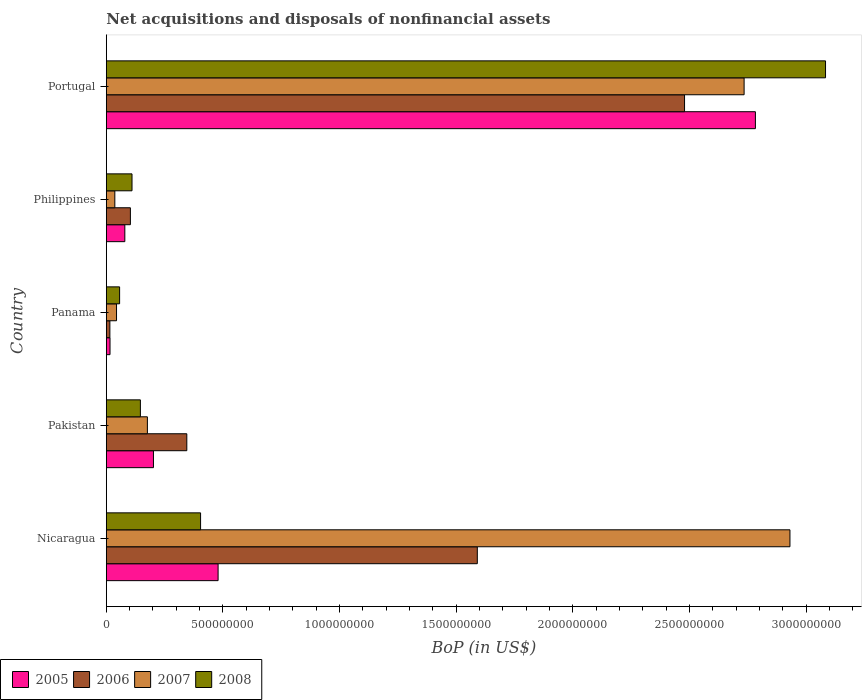How many different coloured bars are there?
Give a very brief answer. 4. Are the number of bars on each tick of the Y-axis equal?
Your answer should be compact. Yes. How many bars are there on the 4th tick from the top?
Give a very brief answer. 4. How many bars are there on the 5th tick from the bottom?
Make the answer very short. 4. In how many cases, is the number of bars for a given country not equal to the number of legend labels?
Your answer should be compact. 0. What is the Balance of Payments in 2006 in Pakistan?
Keep it short and to the point. 3.45e+08. Across all countries, what is the maximum Balance of Payments in 2005?
Ensure brevity in your answer.  2.78e+09. Across all countries, what is the minimum Balance of Payments in 2006?
Offer a very short reply. 1.52e+07. In which country was the Balance of Payments in 2005 maximum?
Give a very brief answer. Portugal. In which country was the Balance of Payments in 2008 minimum?
Make the answer very short. Panama. What is the total Balance of Payments in 2007 in the graph?
Provide a succinct answer. 5.92e+09. What is the difference between the Balance of Payments in 2007 in Panama and that in Portugal?
Ensure brevity in your answer.  -2.69e+09. What is the difference between the Balance of Payments in 2007 in Portugal and the Balance of Payments in 2006 in Pakistan?
Your answer should be compact. 2.39e+09. What is the average Balance of Payments in 2005 per country?
Keep it short and to the point. 7.12e+08. What is the difference between the Balance of Payments in 2007 and Balance of Payments in 2005 in Portugal?
Provide a short and direct response. -4.84e+07. In how many countries, is the Balance of Payments in 2007 greater than 2500000000 US$?
Offer a terse response. 2. What is the ratio of the Balance of Payments in 2006 in Philippines to that in Portugal?
Your answer should be very brief. 0.04. Is the difference between the Balance of Payments in 2007 in Panama and Philippines greater than the difference between the Balance of Payments in 2005 in Panama and Philippines?
Provide a succinct answer. Yes. What is the difference between the highest and the second highest Balance of Payments in 2006?
Offer a very short reply. 8.88e+08. What is the difference between the highest and the lowest Balance of Payments in 2005?
Your response must be concise. 2.77e+09. In how many countries, is the Balance of Payments in 2005 greater than the average Balance of Payments in 2005 taken over all countries?
Give a very brief answer. 1. Is it the case that in every country, the sum of the Balance of Payments in 2008 and Balance of Payments in 2006 is greater than the Balance of Payments in 2007?
Offer a terse response. No. How many countries are there in the graph?
Offer a terse response. 5. Are the values on the major ticks of X-axis written in scientific E-notation?
Your answer should be very brief. No. Does the graph contain any zero values?
Keep it short and to the point. No. Where does the legend appear in the graph?
Offer a very short reply. Bottom left. How are the legend labels stacked?
Your response must be concise. Horizontal. What is the title of the graph?
Provide a succinct answer. Net acquisitions and disposals of nonfinancial assets. Does "2007" appear as one of the legend labels in the graph?
Offer a terse response. Yes. What is the label or title of the X-axis?
Ensure brevity in your answer.  BoP (in US$). What is the BoP (in US$) of 2005 in Nicaragua?
Your answer should be compact. 4.79e+08. What is the BoP (in US$) of 2006 in Nicaragua?
Ensure brevity in your answer.  1.59e+09. What is the BoP (in US$) in 2007 in Nicaragua?
Keep it short and to the point. 2.93e+09. What is the BoP (in US$) of 2008 in Nicaragua?
Offer a terse response. 4.04e+08. What is the BoP (in US$) of 2005 in Pakistan?
Offer a terse response. 2.02e+08. What is the BoP (in US$) in 2006 in Pakistan?
Provide a short and direct response. 3.45e+08. What is the BoP (in US$) in 2007 in Pakistan?
Keep it short and to the point. 1.76e+08. What is the BoP (in US$) in 2008 in Pakistan?
Keep it short and to the point. 1.46e+08. What is the BoP (in US$) in 2005 in Panama?
Offer a very short reply. 1.58e+07. What is the BoP (in US$) in 2006 in Panama?
Keep it short and to the point. 1.52e+07. What is the BoP (in US$) of 2007 in Panama?
Make the answer very short. 4.37e+07. What is the BoP (in US$) in 2008 in Panama?
Ensure brevity in your answer.  5.69e+07. What is the BoP (in US$) in 2005 in Philippines?
Make the answer very short. 7.93e+07. What is the BoP (in US$) of 2006 in Philippines?
Ensure brevity in your answer.  1.03e+08. What is the BoP (in US$) in 2007 in Philippines?
Your answer should be very brief. 3.64e+07. What is the BoP (in US$) of 2008 in Philippines?
Your answer should be compact. 1.10e+08. What is the BoP (in US$) in 2005 in Portugal?
Your response must be concise. 2.78e+09. What is the BoP (in US$) of 2006 in Portugal?
Offer a terse response. 2.48e+09. What is the BoP (in US$) of 2007 in Portugal?
Your response must be concise. 2.73e+09. What is the BoP (in US$) in 2008 in Portugal?
Make the answer very short. 3.08e+09. Across all countries, what is the maximum BoP (in US$) in 2005?
Your response must be concise. 2.78e+09. Across all countries, what is the maximum BoP (in US$) of 2006?
Ensure brevity in your answer.  2.48e+09. Across all countries, what is the maximum BoP (in US$) of 2007?
Keep it short and to the point. 2.93e+09. Across all countries, what is the maximum BoP (in US$) of 2008?
Provide a short and direct response. 3.08e+09. Across all countries, what is the minimum BoP (in US$) of 2005?
Offer a terse response. 1.58e+07. Across all countries, what is the minimum BoP (in US$) of 2006?
Your answer should be compact. 1.52e+07. Across all countries, what is the minimum BoP (in US$) of 2007?
Your answer should be very brief. 3.64e+07. Across all countries, what is the minimum BoP (in US$) of 2008?
Keep it short and to the point. 5.69e+07. What is the total BoP (in US$) of 2005 in the graph?
Provide a short and direct response. 3.56e+09. What is the total BoP (in US$) in 2006 in the graph?
Provide a short and direct response. 4.53e+09. What is the total BoP (in US$) of 2007 in the graph?
Your response must be concise. 5.92e+09. What is the total BoP (in US$) of 2008 in the graph?
Make the answer very short. 3.80e+09. What is the difference between the BoP (in US$) of 2005 in Nicaragua and that in Pakistan?
Offer a terse response. 2.77e+08. What is the difference between the BoP (in US$) of 2006 in Nicaragua and that in Pakistan?
Ensure brevity in your answer.  1.25e+09. What is the difference between the BoP (in US$) in 2007 in Nicaragua and that in Pakistan?
Your response must be concise. 2.75e+09. What is the difference between the BoP (in US$) of 2008 in Nicaragua and that in Pakistan?
Your answer should be very brief. 2.58e+08. What is the difference between the BoP (in US$) in 2005 in Nicaragua and that in Panama?
Keep it short and to the point. 4.63e+08. What is the difference between the BoP (in US$) in 2006 in Nicaragua and that in Panama?
Your answer should be very brief. 1.58e+09. What is the difference between the BoP (in US$) of 2007 in Nicaragua and that in Panama?
Offer a terse response. 2.89e+09. What is the difference between the BoP (in US$) in 2008 in Nicaragua and that in Panama?
Give a very brief answer. 3.47e+08. What is the difference between the BoP (in US$) in 2005 in Nicaragua and that in Philippines?
Your answer should be very brief. 4.00e+08. What is the difference between the BoP (in US$) in 2006 in Nicaragua and that in Philippines?
Provide a succinct answer. 1.49e+09. What is the difference between the BoP (in US$) of 2007 in Nicaragua and that in Philippines?
Ensure brevity in your answer.  2.89e+09. What is the difference between the BoP (in US$) of 2008 in Nicaragua and that in Philippines?
Offer a very short reply. 2.94e+08. What is the difference between the BoP (in US$) of 2005 in Nicaragua and that in Portugal?
Provide a succinct answer. -2.30e+09. What is the difference between the BoP (in US$) in 2006 in Nicaragua and that in Portugal?
Your answer should be compact. -8.88e+08. What is the difference between the BoP (in US$) in 2007 in Nicaragua and that in Portugal?
Offer a terse response. 1.97e+08. What is the difference between the BoP (in US$) of 2008 in Nicaragua and that in Portugal?
Provide a succinct answer. -2.68e+09. What is the difference between the BoP (in US$) in 2005 in Pakistan and that in Panama?
Your answer should be compact. 1.86e+08. What is the difference between the BoP (in US$) of 2006 in Pakistan and that in Panama?
Give a very brief answer. 3.30e+08. What is the difference between the BoP (in US$) of 2007 in Pakistan and that in Panama?
Make the answer very short. 1.32e+08. What is the difference between the BoP (in US$) in 2008 in Pakistan and that in Panama?
Ensure brevity in your answer.  8.91e+07. What is the difference between the BoP (in US$) of 2005 in Pakistan and that in Philippines?
Your response must be concise. 1.23e+08. What is the difference between the BoP (in US$) of 2006 in Pakistan and that in Philippines?
Make the answer very short. 2.42e+08. What is the difference between the BoP (in US$) of 2007 in Pakistan and that in Philippines?
Offer a very short reply. 1.40e+08. What is the difference between the BoP (in US$) of 2008 in Pakistan and that in Philippines?
Your answer should be very brief. 3.59e+07. What is the difference between the BoP (in US$) in 2005 in Pakistan and that in Portugal?
Your answer should be very brief. -2.58e+09. What is the difference between the BoP (in US$) in 2006 in Pakistan and that in Portugal?
Ensure brevity in your answer.  -2.13e+09. What is the difference between the BoP (in US$) in 2007 in Pakistan and that in Portugal?
Your answer should be compact. -2.56e+09. What is the difference between the BoP (in US$) of 2008 in Pakistan and that in Portugal?
Ensure brevity in your answer.  -2.94e+09. What is the difference between the BoP (in US$) of 2005 in Panama and that in Philippines?
Provide a succinct answer. -6.35e+07. What is the difference between the BoP (in US$) of 2006 in Panama and that in Philippines?
Your response must be concise. -8.79e+07. What is the difference between the BoP (in US$) in 2007 in Panama and that in Philippines?
Provide a succinct answer. 7.26e+06. What is the difference between the BoP (in US$) in 2008 in Panama and that in Philippines?
Give a very brief answer. -5.32e+07. What is the difference between the BoP (in US$) in 2005 in Panama and that in Portugal?
Provide a short and direct response. -2.77e+09. What is the difference between the BoP (in US$) of 2006 in Panama and that in Portugal?
Ensure brevity in your answer.  -2.46e+09. What is the difference between the BoP (in US$) of 2007 in Panama and that in Portugal?
Offer a terse response. -2.69e+09. What is the difference between the BoP (in US$) of 2008 in Panama and that in Portugal?
Provide a succinct answer. -3.03e+09. What is the difference between the BoP (in US$) of 2005 in Philippines and that in Portugal?
Your answer should be very brief. -2.70e+09. What is the difference between the BoP (in US$) in 2006 in Philippines and that in Portugal?
Your response must be concise. -2.38e+09. What is the difference between the BoP (in US$) of 2007 in Philippines and that in Portugal?
Offer a terse response. -2.70e+09. What is the difference between the BoP (in US$) of 2008 in Philippines and that in Portugal?
Provide a succinct answer. -2.97e+09. What is the difference between the BoP (in US$) of 2005 in Nicaragua and the BoP (in US$) of 2006 in Pakistan?
Provide a short and direct response. 1.34e+08. What is the difference between the BoP (in US$) in 2005 in Nicaragua and the BoP (in US$) in 2007 in Pakistan?
Keep it short and to the point. 3.03e+08. What is the difference between the BoP (in US$) in 2005 in Nicaragua and the BoP (in US$) in 2008 in Pakistan?
Keep it short and to the point. 3.33e+08. What is the difference between the BoP (in US$) in 2006 in Nicaragua and the BoP (in US$) in 2007 in Pakistan?
Your answer should be very brief. 1.41e+09. What is the difference between the BoP (in US$) of 2006 in Nicaragua and the BoP (in US$) of 2008 in Pakistan?
Your answer should be very brief. 1.44e+09. What is the difference between the BoP (in US$) of 2007 in Nicaragua and the BoP (in US$) of 2008 in Pakistan?
Make the answer very short. 2.78e+09. What is the difference between the BoP (in US$) of 2005 in Nicaragua and the BoP (in US$) of 2006 in Panama?
Your answer should be very brief. 4.64e+08. What is the difference between the BoP (in US$) of 2005 in Nicaragua and the BoP (in US$) of 2007 in Panama?
Your answer should be compact. 4.35e+08. What is the difference between the BoP (in US$) in 2005 in Nicaragua and the BoP (in US$) in 2008 in Panama?
Offer a terse response. 4.22e+08. What is the difference between the BoP (in US$) in 2006 in Nicaragua and the BoP (in US$) in 2007 in Panama?
Ensure brevity in your answer.  1.55e+09. What is the difference between the BoP (in US$) in 2006 in Nicaragua and the BoP (in US$) in 2008 in Panama?
Provide a succinct answer. 1.53e+09. What is the difference between the BoP (in US$) in 2007 in Nicaragua and the BoP (in US$) in 2008 in Panama?
Your response must be concise. 2.87e+09. What is the difference between the BoP (in US$) of 2005 in Nicaragua and the BoP (in US$) of 2006 in Philippines?
Your answer should be compact. 3.76e+08. What is the difference between the BoP (in US$) of 2005 in Nicaragua and the BoP (in US$) of 2007 in Philippines?
Your answer should be compact. 4.43e+08. What is the difference between the BoP (in US$) in 2005 in Nicaragua and the BoP (in US$) in 2008 in Philippines?
Provide a short and direct response. 3.69e+08. What is the difference between the BoP (in US$) in 2006 in Nicaragua and the BoP (in US$) in 2007 in Philippines?
Make the answer very short. 1.55e+09. What is the difference between the BoP (in US$) in 2006 in Nicaragua and the BoP (in US$) in 2008 in Philippines?
Your answer should be compact. 1.48e+09. What is the difference between the BoP (in US$) in 2007 in Nicaragua and the BoP (in US$) in 2008 in Philippines?
Provide a short and direct response. 2.82e+09. What is the difference between the BoP (in US$) in 2005 in Nicaragua and the BoP (in US$) in 2006 in Portugal?
Give a very brief answer. -2.00e+09. What is the difference between the BoP (in US$) in 2005 in Nicaragua and the BoP (in US$) in 2007 in Portugal?
Provide a succinct answer. -2.25e+09. What is the difference between the BoP (in US$) of 2005 in Nicaragua and the BoP (in US$) of 2008 in Portugal?
Make the answer very short. -2.60e+09. What is the difference between the BoP (in US$) in 2006 in Nicaragua and the BoP (in US$) in 2007 in Portugal?
Offer a terse response. -1.14e+09. What is the difference between the BoP (in US$) in 2006 in Nicaragua and the BoP (in US$) in 2008 in Portugal?
Offer a terse response. -1.49e+09. What is the difference between the BoP (in US$) of 2007 in Nicaragua and the BoP (in US$) of 2008 in Portugal?
Offer a terse response. -1.52e+08. What is the difference between the BoP (in US$) in 2005 in Pakistan and the BoP (in US$) in 2006 in Panama?
Provide a succinct answer. 1.87e+08. What is the difference between the BoP (in US$) of 2005 in Pakistan and the BoP (in US$) of 2007 in Panama?
Your answer should be very brief. 1.58e+08. What is the difference between the BoP (in US$) in 2005 in Pakistan and the BoP (in US$) in 2008 in Panama?
Ensure brevity in your answer.  1.45e+08. What is the difference between the BoP (in US$) in 2006 in Pakistan and the BoP (in US$) in 2007 in Panama?
Provide a succinct answer. 3.01e+08. What is the difference between the BoP (in US$) in 2006 in Pakistan and the BoP (in US$) in 2008 in Panama?
Your answer should be compact. 2.88e+08. What is the difference between the BoP (in US$) in 2007 in Pakistan and the BoP (in US$) in 2008 in Panama?
Provide a short and direct response. 1.19e+08. What is the difference between the BoP (in US$) in 2005 in Pakistan and the BoP (in US$) in 2006 in Philippines?
Provide a succinct answer. 9.89e+07. What is the difference between the BoP (in US$) of 2005 in Pakistan and the BoP (in US$) of 2007 in Philippines?
Your response must be concise. 1.66e+08. What is the difference between the BoP (in US$) in 2005 in Pakistan and the BoP (in US$) in 2008 in Philippines?
Ensure brevity in your answer.  9.19e+07. What is the difference between the BoP (in US$) of 2006 in Pakistan and the BoP (in US$) of 2007 in Philippines?
Your answer should be very brief. 3.09e+08. What is the difference between the BoP (in US$) in 2006 in Pakistan and the BoP (in US$) in 2008 in Philippines?
Keep it short and to the point. 2.35e+08. What is the difference between the BoP (in US$) of 2007 in Pakistan and the BoP (in US$) of 2008 in Philippines?
Your answer should be very brief. 6.59e+07. What is the difference between the BoP (in US$) of 2005 in Pakistan and the BoP (in US$) of 2006 in Portugal?
Your answer should be very brief. -2.28e+09. What is the difference between the BoP (in US$) of 2005 in Pakistan and the BoP (in US$) of 2007 in Portugal?
Provide a succinct answer. -2.53e+09. What is the difference between the BoP (in US$) in 2005 in Pakistan and the BoP (in US$) in 2008 in Portugal?
Your answer should be compact. -2.88e+09. What is the difference between the BoP (in US$) in 2006 in Pakistan and the BoP (in US$) in 2007 in Portugal?
Give a very brief answer. -2.39e+09. What is the difference between the BoP (in US$) in 2006 in Pakistan and the BoP (in US$) in 2008 in Portugal?
Provide a short and direct response. -2.74e+09. What is the difference between the BoP (in US$) of 2007 in Pakistan and the BoP (in US$) of 2008 in Portugal?
Provide a succinct answer. -2.91e+09. What is the difference between the BoP (in US$) of 2005 in Panama and the BoP (in US$) of 2006 in Philippines?
Make the answer very short. -8.73e+07. What is the difference between the BoP (in US$) of 2005 in Panama and the BoP (in US$) of 2007 in Philippines?
Your answer should be very brief. -2.06e+07. What is the difference between the BoP (in US$) in 2005 in Panama and the BoP (in US$) in 2008 in Philippines?
Ensure brevity in your answer.  -9.43e+07. What is the difference between the BoP (in US$) in 2006 in Panama and the BoP (in US$) in 2007 in Philippines?
Your response must be concise. -2.12e+07. What is the difference between the BoP (in US$) in 2006 in Panama and the BoP (in US$) in 2008 in Philippines?
Offer a very short reply. -9.49e+07. What is the difference between the BoP (in US$) of 2007 in Panama and the BoP (in US$) of 2008 in Philippines?
Your answer should be very brief. -6.64e+07. What is the difference between the BoP (in US$) in 2005 in Panama and the BoP (in US$) in 2006 in Portugal?
Provide a succinct answer. -2.46e+09. What is the difference between the BoP (in US$) of 2005 in Panama and the BoP (in US$) of 2007 in Portugal?
Provide a short and direct response. -2.72e+09. What is the difference between the BoP (in US$) of 2005 in Panama and the BoP (in US$) of 2008 in Portugal?
Give a very brief answer. -3.07e+09. What is the difference between the BoP (in US$) of 2006 in Panama and the BoP (in US$) of 2007 in Portugal?
Provide a succinct answer. -2.72e+09. What is the difference between the BoP (in US$) of 2006 in Panama and the BoP (in US$) of 2008 in Portugal?
Provide a succinct answer. -3.07e+09. What is the difference between the BoP (in US$) in 2007 in Panama and the BoP (in US$) in 2008 in Portugal?
Offer a terse response. -3.04e+09. What is the difference between the BoP (in US$) of 2005 in Philippines and the BoP (in US$) of 2006 in Portugal?
Offer a terse response. -2.40e+09. What is the difference between the BoP (in US$) of 2005 in Philippines and the BoP (in US$) of 2007 in Portugal?
Provide a short and direct response. -2.65e+09. What is the difference between the BoP (in US$) of 2005 in Philippines and the BoP (in US$) of 2008 in Portugal?
Make the answer very short. -3.00e+09. What is the difference between the BoP (in US$) of 2006 in Philippines and the BoP (in US$) of 2007 in Portugal?
Provide a succinct answer. -2.63e+09. What is the difference between the BoP (in US$) in 2006 in Philippines and the BoP (in US$) in 2008 in Portugal?
Offer a terse response. -2.98e+09. What is the difference between the BoP (in US$) in 2007 in Philippines and the BoP (in US$) in 2008 in Portugal?
Your answer should be compact. -3.05e+09. What is the average BoP (in US$) in 2005 per country?
Ensure brevity in your answer.  7.12e+08. What is the average BoP (in US$) in 2006 per country?
Offer a terse response. 9.06e+08. What is the average BoP (in US$) of 2007 per country?
Provide a short and direct response. 1.18e+09. What is the average BoP (in US$) of 2008 per country?
Give a very brief answer. 7.60e+08. What is the difference between the BoP (in US$) of 2005 and BoP (in US$) of 2006 in Nicaragua?
Offer a terse response. -1.11e+09. What is the difference between the BoP (in US$) of 2005 and BoP (in US$) of 2007 in Nicaragua?
Make the answer very short. -2.45e+09. What is the difference between the BoP (in US$) in 2005 and BoP (in US$) in 2008 in Nicaragua?
Give a very brief answer. 7.51e+07. What is the difference between the BoP (in US$) in 2006 and BoP (in US$) in 2007 in Nicaragua?
Provide a succinct answer. -1.34e+09. What is the difference between the BoP (in US$) in 2006 and BoP (in US$) in 2008 in Nicaragua?
Your answer should be compact. 1.19e+09. What is the difference between the BoP (in US$) of 2007 and BoP (in US$) of 2008 in Nicaragua?
Offer a terse response. 2.53e+09. What is the difference between the BoP (in US$) in 2005 and BoP (in US$) in 2006 in Pakistan?
Ensure brevity in your answer.  -1.43e+08. What is the difference between the BoP (in US$) in 2005 and BoP (in US$) in 2007 in Pakistan?
Offer a terse response. 2.60e+07. What is the difference between the BoP (in US$) of 2005 and BoP (in US$) of 2008 in Pakistan?
Keep it short and to the point. 5.60e+07. What is the difference between the BoP (in US$) of 2006 and BoP (in US$) of 2007 in Pakistan?
Provide a short and direct response. 1.69e+08. What is the difference between the BoP (in US$) of 2006 and BoP (in US$) of 2008 in Pakistan?
Your response must be concise. 1.99e+08. What is the difference between the BoP (in US$) of 2007 and BoP (in US$) of 2008 in Pakistan?
Make the answer very short. 3.00e+07. What is the difference between the BoP (in US$) of 2005 and BoP (in US$) of 2006 in Panama?
Your answer should be very brief. 6.00e+05. What is the difference between the BoP (in US$) of 2005 and BoP (in US$) of 2007 in Panama?
Your response must be concise. -2.79e+07. What is the difference between the BoP (in US$) in 2005 and BoP (in US$) in 2008 in Panama?
Your answer should be very brief. -4.11e+07. What is the difference between the BoP (in US$) of 2006 and BoP (in US$) of 2007 in Panama?
Provide a short and direct response. -2.85e+07. What is the difference between the BoP (in US$) of 2006 and BoP (in US$) of 2008 in Panama?
Make the answer very short. -4.17e+07. What is the difference between the BoP (in US$) of 2007 and BoP (in US$) of 2008 in Panama?
Make the answer very short. -1.32e+07. What is the difference between the BoP (in US$) of 2005 and BoP (in US$) of 2006 in Philippines?
Make the answer very short. -2.38e+07. What is the difference between the BoP (in US$) in 2005 and BoP (in US$) in 2007 in Philippines?
Your answer should be compact. 4.28e+07. What is the difference between the BoP (in US$) in 2005 and BoP (in US$) in 2008 in Philippines?
Keep it short and to the point. -3.08e+07. What is the difference between the BoP (in US$) of 2006 and BoP (in US$) of 2007 in Philippines?
Provide a short and direct response. 6.67e+07. What is the difference between the BoP (in US$) in 2006 and BoP (in US$) in 2008 in Philippines?
Your answer should be very brief. -6.96e+06. What is the difference between the BoP (in US$) of 2007 and BoP (in US$) of 2008 in Philippines?
Ensure brevity in your answer.  -7.36e+07. What is the difference between the BoP (in US$) of 2005 and BoP (in US$) of 2006 in Portugal?
Your answer should be very brief. 3.04e+08. What is the difference between the BoP (in US$) in 2005 and BoP (in US$) in 2007 in Portugal?
Provide a succinct answer. 4.84e+07. What is the difference between the BoP (in US$) of 2005 and BoP (in US$) of 2008 in Portugal?
Your answer should be very brief. -3.01e+08. What is the difference between the BoP (in US$) of 2006 and BoP (in US$) of 2007 in Portugal?
Provide a short and direct response. -2.55e+08. What is the difference between the BoP (in US$) in 2006 and BoP (in US$) in 2008 in Portugal?
Provide a succinct answer. -6.04e+08. What is the difference between the BoP (in US$) of 2007 and BoP (in US$) of 2008 in Portugal?
Ensure brevity in your answer.  -3.49e+08. What is the ratio of the BoP (in US$) of 2005 in Nicaragua to that in Pakistan?
Your answer should be compact. 2.37. What is the ratio of the BoP (in US$) of 2006 in Nicaragua to that in Pakistan?
Ensure brevity in your answer.  4.61. What is the ratio of the BoP (in US$) of 2007 in Nicaragua to that in Pakistan?
Your answer should be very brief. 16.65. What is the ratio of the BoP (in US$) of 2008 in Nicaragua to that in Pakistan?
Your response must be concise. 2.77. What is the ratio of the BoP (in US$) in 2005 in Nicaragua to that in Panama?
Your answer should be compact. 30.32. What is the ratio of the BoP (in US$) in 2006 in Nicaragua to that in Panama?
Your answer should be compact. 104.62. What is the ratio of the BoP (in US$) of 2007 in Nicaragua to that in Panama?
Provide a succinct answer. 67.06. What is the ratio of the BoP (in US$) in 2008 in Nicaragua to that in Panama?
Provide a short and direct response. 7.1. What is the ratio of the BoP (in US$) of 2005 in Nicaragua to that in Philippines?
Ensure brevity in your answer.  6.04. What is the ratio of the BoP (in US$) in 2006 in Nicaragua to that in Philippines?
Make the answer very short. 15.42. What is the ratio of the BoP (in US$) of 2007 in Nicaragua to that in Philippines?
Make the answer very short. 80.41. What is the ratio of the BoP (in US$) in 2008 in Nicaragua to that in Philippines?
Offer a very short reply. 3.67. What is the ratio of the BoP (in US$) of 2005 in Nicaragua to that in Portugal?
Your response must be concise. 0.17. What is the ratio of the BoP (in US$) of 2006 in Nicaragua to that in Portugal?
Ensure brevity in your answer.  0.64. What is the ratio of the BoP (in US$) in 2007 in Nicaragua to that in Portugal?
Your answer should be very brief. 1.07. What is the ratio of the BoP (in US$) of 2008 in Nicaragua to that in Portugal?
Give a very brief answer. 0.13. What is the ratio of the BoP (in US$) in 2005 in Pakistan to that in Panama?
Give a very brief answer. 12.78. What is the ratio of the BoP (in US$) in 2006 in Pakistan to that in Panama?
Keep it short and to the point. 22.7. What is the ratio of the BoP (in US$) of 2007 in Pakistan to that in Panama?
Provide a short and direct response. 4.03. What is the ratio of the BoP (in US$) of 2008 in Pakistan to that in Panama?
Keep it short and to the point. 2.57. What is the ratio of the BoP (in US$) in 2005 in Pakistan to that in Philippines?
Give a very brief answer. 2.55. What is the ratio of the BoP (in US$) of 2006 in Pakistan to that in Philippines?
Ensure brevity in your answer.  3.35. What is the ratio of the BoP (in US$) in 2007 in Pakistan to that in Philippines?
Offer a terse response. 4.83. What is the ratio of the BoP (in US$) of 2008 in Pakistan to that in Philippines?
Offer a very short reply. 1.33. What is the ratio of the BoP (in US$) in 2005 in Pakistan to that in Portugal?
Offer a terse response. 0.07. What is the ratio of the BoP (in US$) of 2006 in Pakistan to that in Portugal?
Make the answer very short. 0.14. What is the ratio of the BoP (in US$) of 2007 in Pakistan to that in Portugal?
Give a very brief answer. 0.06. What is the ratio of the BoP (in US$) in 2008 in Pakistan to that in Portugal?
Your answer should be compact. 0.05. What is the ratio of the BoP (in US$) in 2005 in Panama to that in Philippines?
Make the answer very short. 0.2. What is the ratio of the BoP (in US$) in 2006 in Panama to that in Philippines?
Offer a terse response. 0.15. What is the ratio of the BoP (in US$) of 2007 in Panama to that in Philippines?
Give a very brief answer. 1.2. What is the ratio of the BoP (in US$) of 2008 in Panama to that in Philippines?
Provide a short and direct response. 0.52. What is the ratio of the BoP (in US$) of 2005 in Panama to that in Portugal?
Make the answer very short. 0.01. What is the ratio of the BoP (in US$) in 2006 in Panama to that in Portugal?
Keep it short and to the point. 0.01. What is the ratio of the BoP (in US$) in 2007 in Panama to that in Portugal?
Offer a very short reply. 0.02. What is the ratio of the BoP (in US$) in 2008 in Panama to that in Portugal?
Make the answer very short. 0.02. What is the ratio of the BoP (in US$) in 2005 in Philippines to that in Portugal?
Make the answer very short. 0.03. What is the ratio of the BoP (in US$) of 2006 in Philippines to that in Portugal?
Ensure brevity in your answer.  0.04. What is the ratio of the BoP (in US$) in 2007 in Philippines to that in Portugal?
Ensure brevity in your answer.  0.01. What is the ratio of the BoP (in US$) in 2008 in Philippines to that in Portugal?
Keep it short and to the point. 0.04. What is the difference between the highest and the second highest BoP (in US$) in 2005?
Offer a very short reply. 2.30e+09. What is the difference between the highest and the second highest BoP (in US$) in 2006?
Provide a succinct answer. 8.88e+08. What is the difference between the highest and the second highest BoP (in US$) in 2007?
Your answer should be compact. 1.97e+08. What is the difference between the highest and the second highest BoP (in US$) of 2008?
Offer a terse response. 2.68e+09. What is the difference between the highest and the lowest BoP (in US$) in 2005?
Your answer should be very brief. 2.77e+09. What is the difference between the highest and the lowest BoP (in US$) of 2006?
Offer a very short reply. 2.46e+09. What is the difference between the highest and the lowest BoP (in US$) in 2007?
Give a very brief answer. 2.89e+09. What is the difference between the highest and the lowest BoP (in US$) of 2008?
Provide a short and direct response. 3.03e+09. 